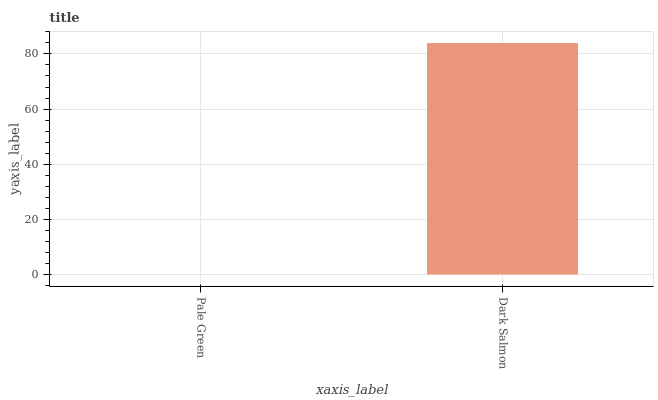Is Pale Green the minimum?
Answer yes or no. Yes. Is Dark Salmon the maximum?
Answer yes or no. Yes. Is Dark Salmon the minimum?
Answer yes or no. No. Is Dark Salmon greater than Pale Green?
Answer yes or no. Yes. Is Pale Green less than Dark Salmon?
Answer yes or no. Yes. Is Pale Green greater than Dark Salmon?
Answer yes or no. No. Is Dark Salmon less than Pale Green?
Answer yes or no. No. Is Dark Salmon the high median?
Answer yes or no. Yes. Is Pale Green the low median?
Answer yes or no. Yes. Is Pale Green the high median?
Answer yes or no. No. Is Dark Salmon the low median?
Answer yes or no. No. 